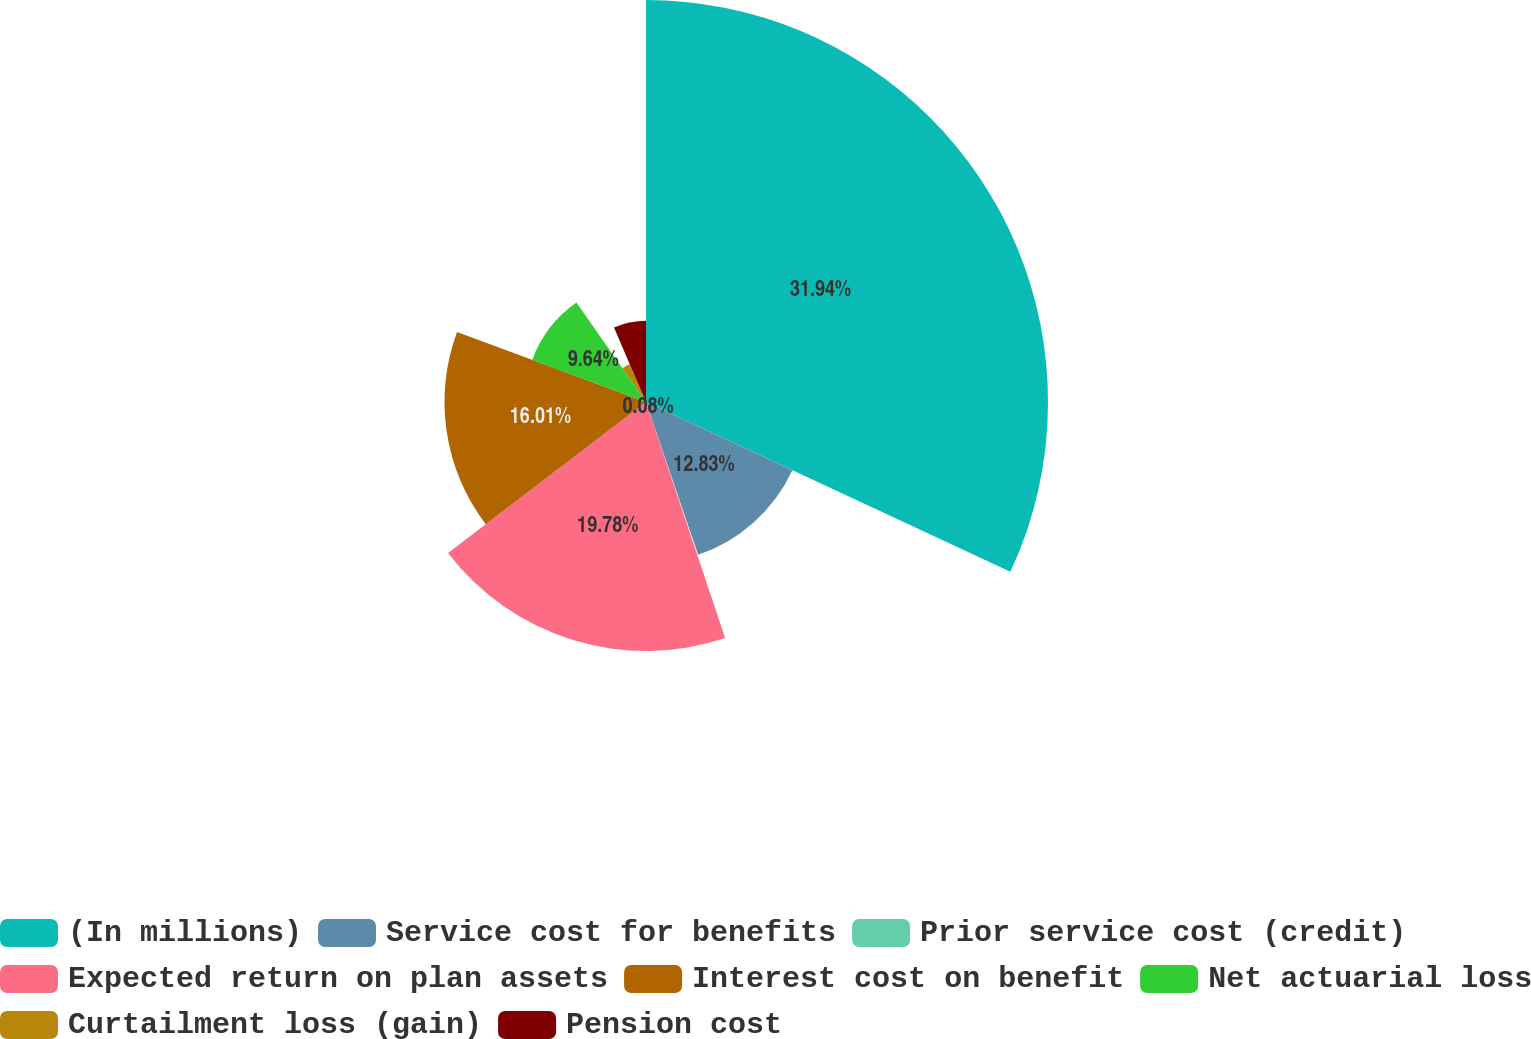Convert chart. <chart><loc_0><loc_0><loc_500><loc_500><pie_chart><fcel>(In millions)<fcel>Service cost for benefits<fcel>Prior service cost (credit)<fcel>Expected return on plan assets<fcel>Interest cost on benefit<fcel>Net actuarial loss<fcel>Curtailment loss (gain)<fcel>Pension cost<nl><fcel>31.94%<fcel>12.83%<fcel>0.08%<fcel>19.78%<fcel>16.01%<fcel>9.64%<fcel>3.27%<fcel>6.45%<nl></chart> 